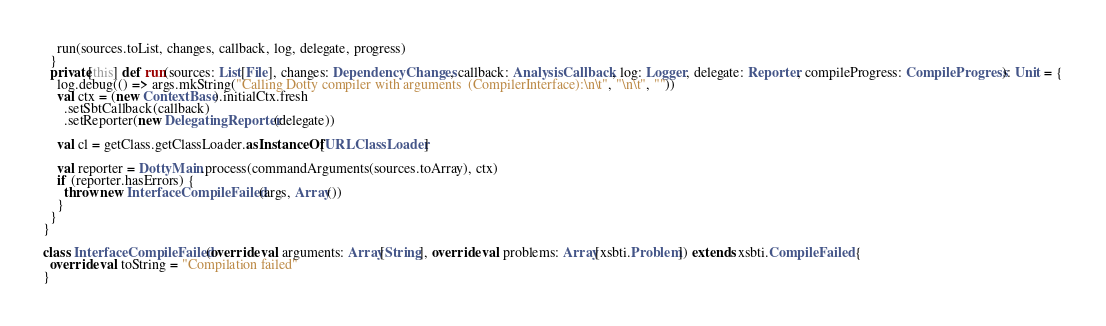<code> <loc_0><loc_0><loc_500><loc_500><_Scala_>    run(sources.toList, changes, callback, log, delegate, progress)
  }
  private[this] def run(sources: List[File], changes: DependencyChanges, callback: AnalysisCallback, log: Logger, delegate: Reporter, compileProgress: CompileProgress): Unit = {
    log.debug(() => args.mkString("Calling Dotty compiler with arguments  (CompilerInterface):\n\t", "\n\t", ""))
    val ctx = (new ContextBase).initialCtx.fresh
      .setSbtCallback(callback)
      .setReporter(new DelegatingReporter(delegate))

    val cl = getClass.getClassLoader.asInstanceOf[URLClassLoader]

    val reporter = DottyMain.process(commandArguments(sources.toArray), ctx)
    if (reporter.hasErrors) {
      throw new InterfaceCompileFailed(args, Array())
    }
  }
}

class InterfaceCompileFailed(override val arguments: Array[String], override val problems: Array[xsbti.Problem]) extends xsbti.CompileFailed {
  override val toString = "Compilation failed"
}
</code> 